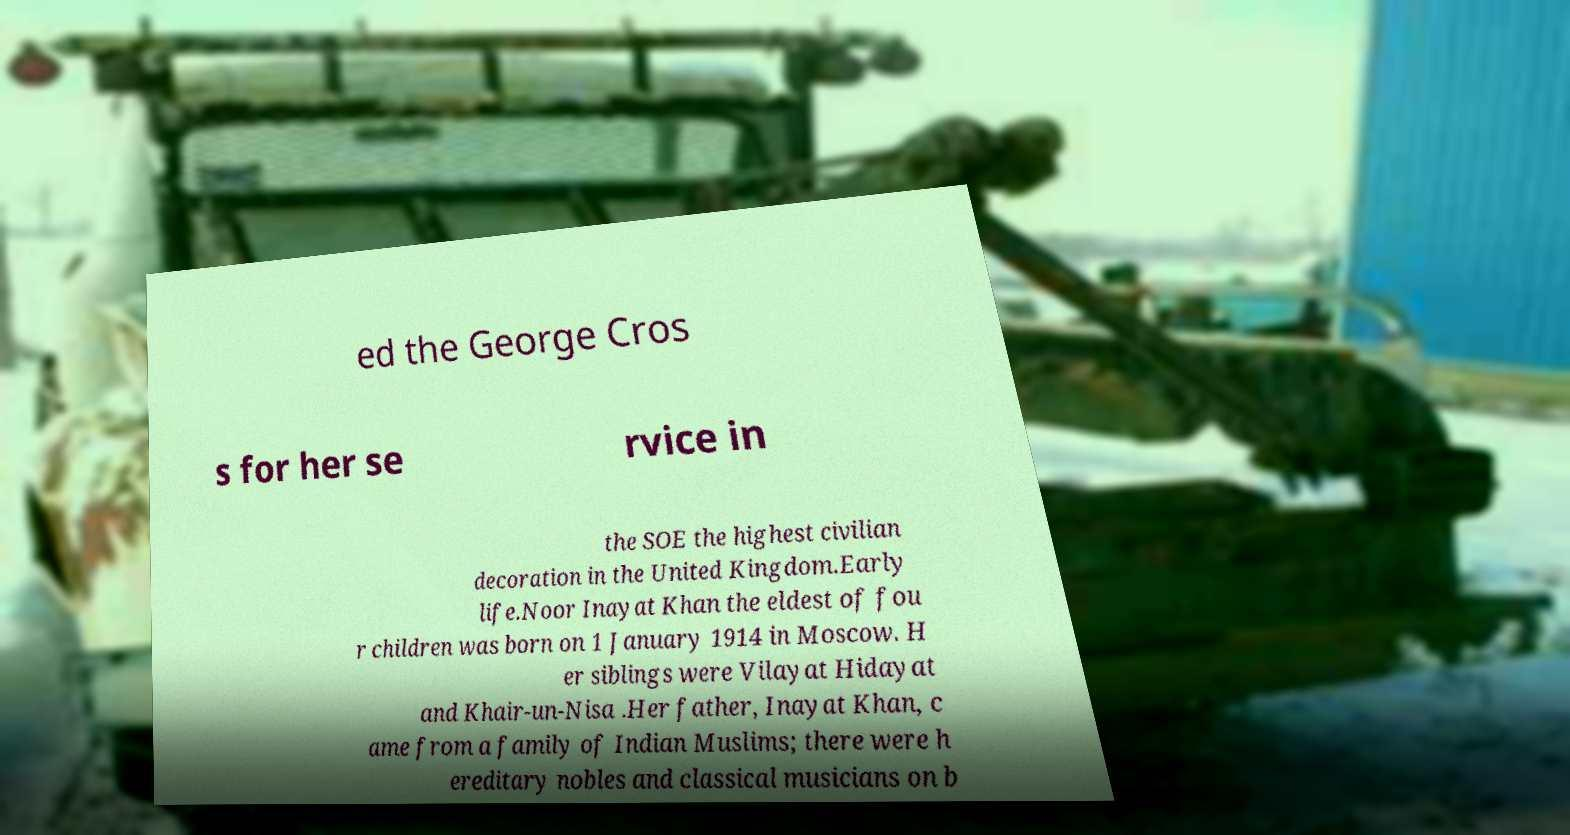For documentation purposes, I need the text within this image transcribed. Could you provide that? ed the George Cros s for her se rvice in the SOE the highest civilian decoration in the United Kingdom.Early life.Noor Inayat Khan the eldest of fou r children was born on 1 January 1914 in Moscow. H er siblings were Vilayat Hidayat and Khair-un-Nisa .Her father, Inayat Khan, c ame from a family of Indian Muslims; there were h ereditary nobles and classical musicians on b 